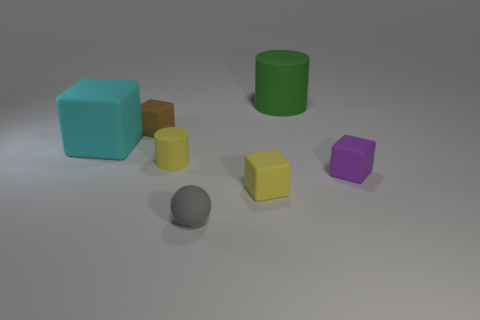Add 3 small gray things. How many objects exist? 10 Subtract all balls. How many objects are left? 6 Subtract all tiny purple matte things. Subtract all balls. How many objects are left? 5 Add 4 big rubber cylinders. How many big rubber cylinders are left? 5 Add 5 green objects. How many green objects exist? 6 Subtract 0 green balls. How many objects are left? 7 